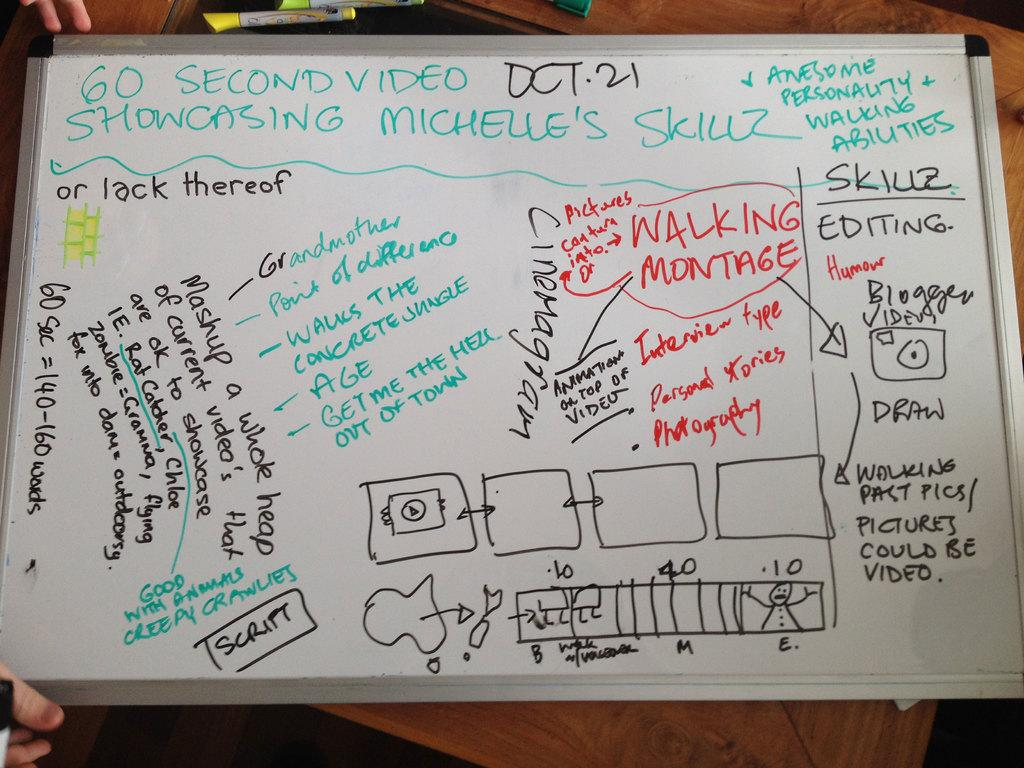Provide a one-sentence caption for the provided image. A dry erase board is covered in notes about editing. 